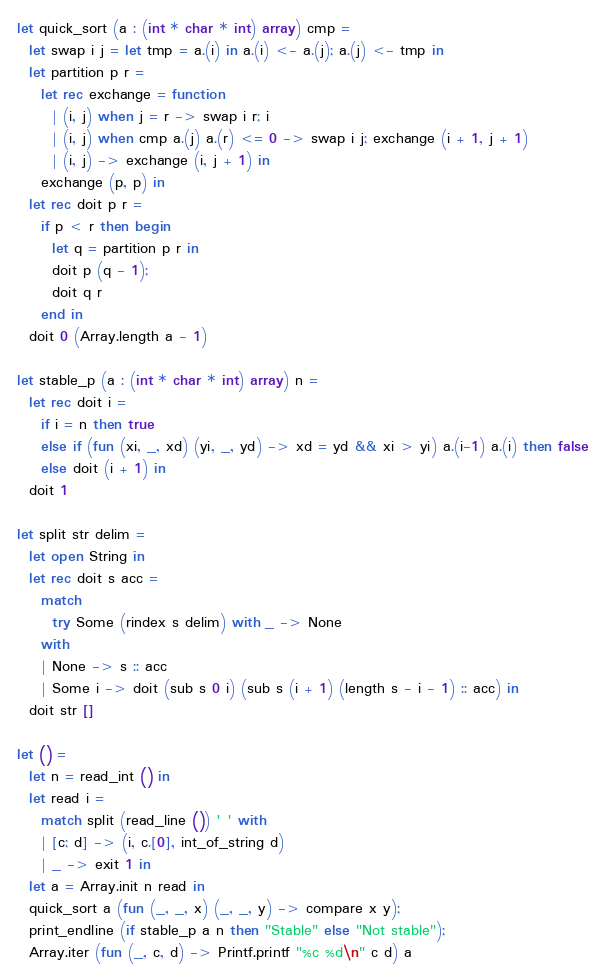<code> <loc_0><loc_0><loc_500><loc_500><_OCaml_>let quick_sort (a : (int * char * int) array) cmp =
  let swap i j = let tmp = a.(i) in a.(i) <- a.(j); a.(j) <- tmp in
  let partition p r =
    let rec exchange = function
      | (i, j) when j = r -> swap i r; i
      | (i, j) when cmp a.(j) a.(r) <= 0 -> swap i j; exchange (i + 1, j + 1)
      | (i, j) -> exchange (i, j + 1) in
    exchange (p, p) in
  let rec doit p r =
    if p < r then begin
      let q = partition p r in
      doit p (q - 1);
      doit q r
    end in
  doit 0 (Array.length a - 1)

let stable_p (a : (int * char * int) array) n =
  let rec doit i =
    if i = n then true
    else if (fun (xi, _, xd) (yi, _, yd) -> xd = yd && xi > yi) a.(i-1) a.(i) then false
    else doit (i + 1) in
  doit 1

let split str delim =
  let open String in
  let rec doit s acc =
    match
      try Some (rindex s delim) with _ -> None
    with
    | None -> s :: acc
    | Some i -> doit (sub s 0 i) (sub s (i + 1) (length s - i - 1) :: acc) in
  doit str []

let () =
  let n = read_int () in
  let read i =
    match split (read_line ()) ' ' with
    | [c; d] -> (i, c.[0], int_of_string d)
    | _ -> exit 1 in
  let a = Array.init n read in
  quick_sort a (fun (_, _, x) (_, _, y) -> compare x y);
  print_endline (if stable_p a n then "Stable" else "Not stable");
  Array.iter (fun (_, c, d) -> Printf.printf "%c %d\n" c d) a</code> 